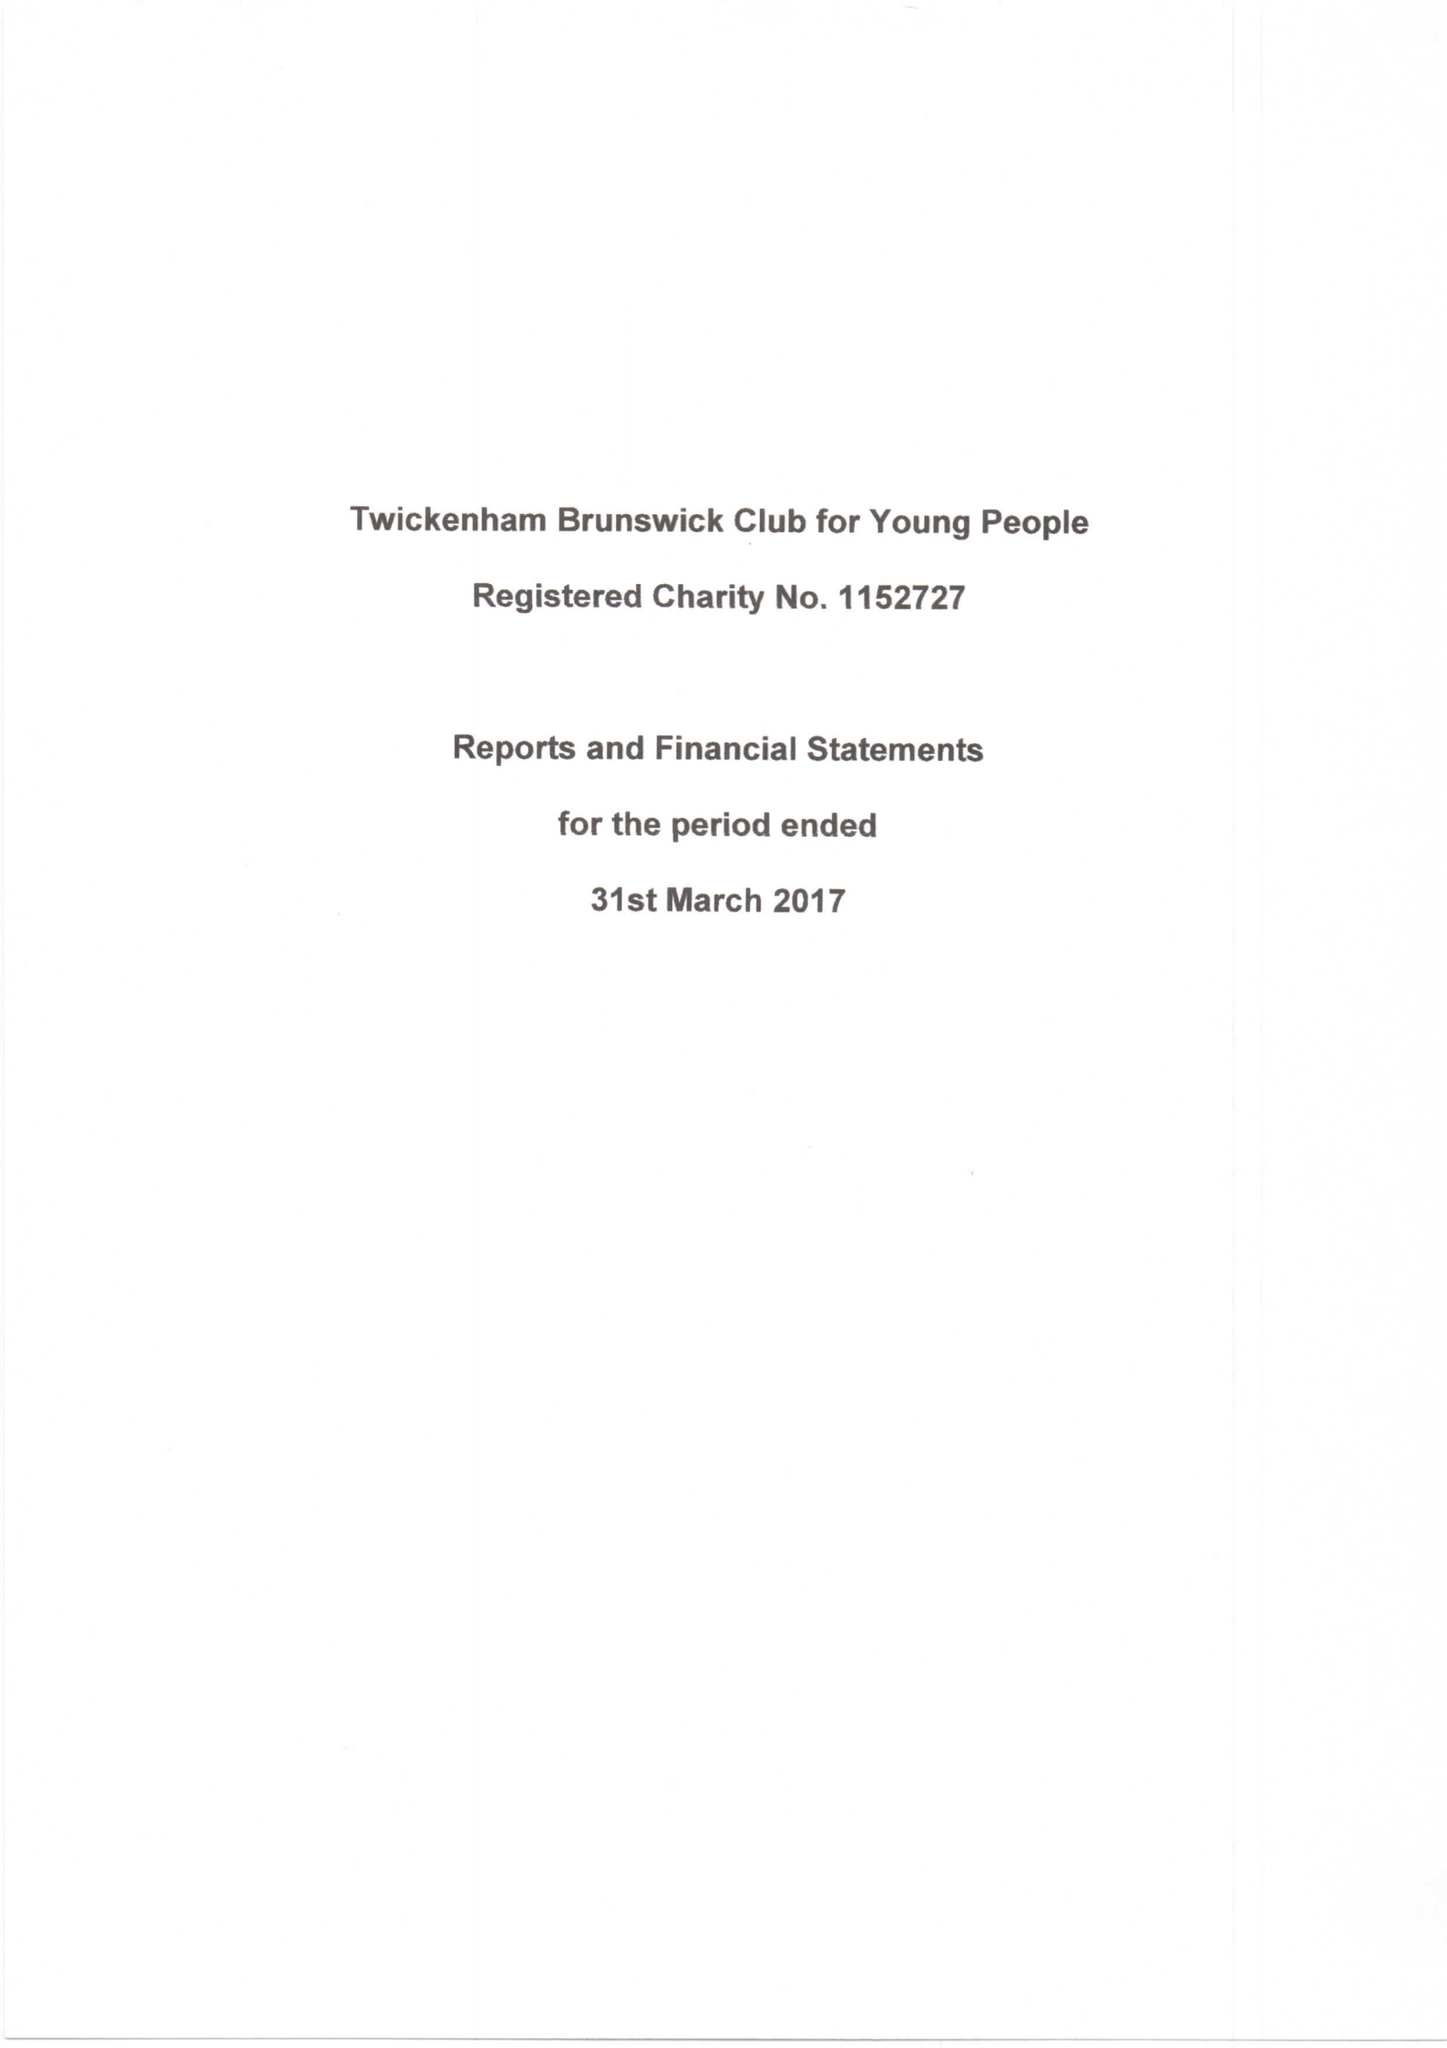What is the value for the address__street_line?
Answer the question using a single word or phrase. CLARENDON CRESCENT 